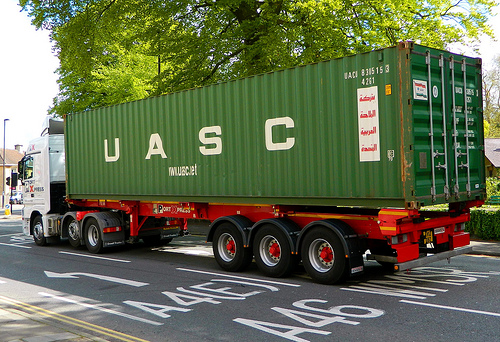Is the color of the bed the sharegpt4v/same as the color of the arrow? No, the bed is not the sharegpt4v/same color as the arrow. 